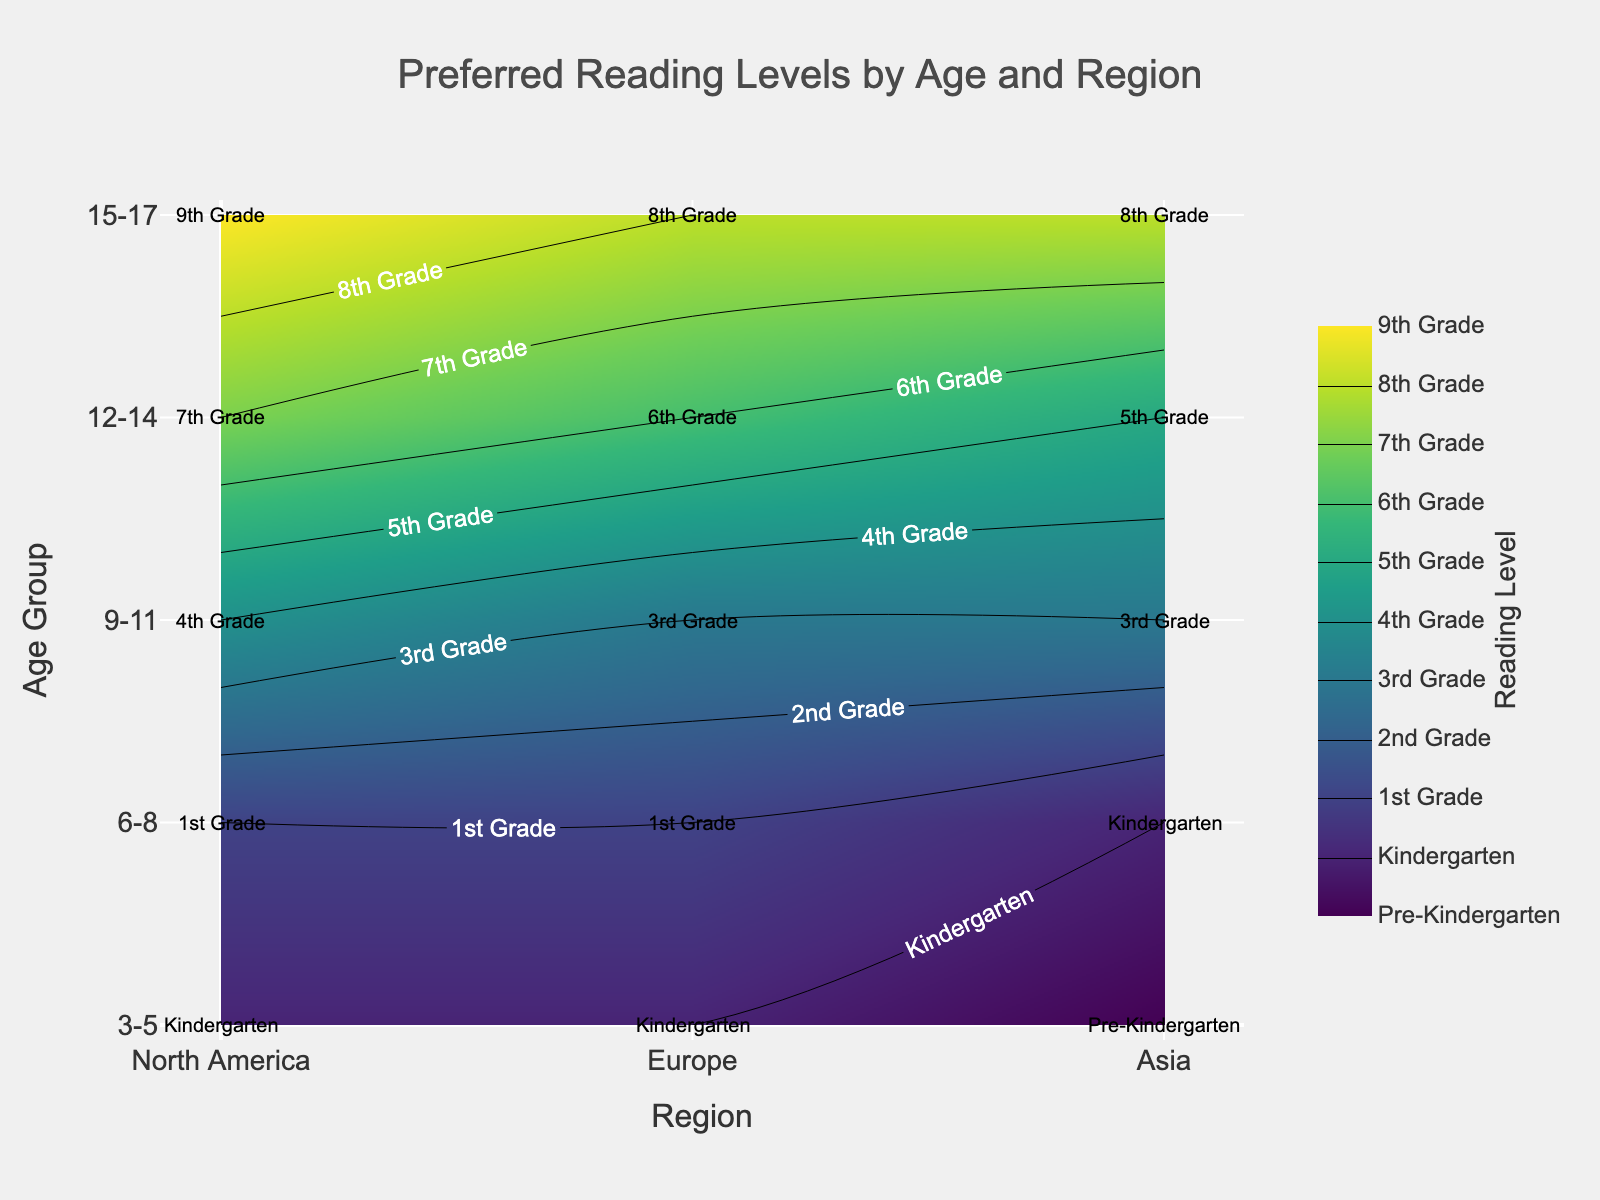What is the title of the figure? The title is displayed at the top of the figure.
Answer: Preferred Reading Levels by Age and Region What does the x-axis represent in this figure? The x-axis represents different regions, which are labeled using text such as North America, Europe, and Asia.
Answer: Regions Which age group prefers Pre-Kindergarten reading level in Asia? From the labels on the plot, we can see that the area corresponding to '3-5' age group and 'Asia' region is marked with 'Pre-Kindergarten'.
Answer: 3-5 What reading level is most preferred by the age group 12-14 in Europe? The plot shows that for the age group '12-14' in the 'Europe' region, the contour label indicates '6th Grade'.
Answer: 6th Grade Compare the preferred reading levels for the 9-11 age group across all regions. Which region has the highest reading level? By examining the contour labels for the 9-11 age group across all regions, we see the labels are '4th Grade' for North America, '3rd Grade' for Europe, and '3rd Grade' for Asia. North America has the highest reading level.
Answer: North America What is the difference in preferred reading levels between the age groups 9-11 and 15-17 in North America? For North America, the plot shows '4th Grade' for the 9-11 age group and '9th Grade' for the 15-17 age group. The difference between these reading levels is 5 grades.
Answer: 5 grades Which reading level is most frequently preferred by children aged 6-8 across all regions? For the age group '6-8', the contour labels indicate '1st Grade' for North America and Europe, and 'Kindergarten' for Asia. '1st Grade' is most frequently preferred.
Answer: 1st Grade What patterns can be observed in the preferred reading levels as age increases across all regions? The contour plot shows an upward trend in reading levels as the age increases in all regions. For example, younger age groups like 3-5 prefer lower levels like 'Kindergarten', while older age groups like 15-17 prefer higher levels like '8th Grade' and '9th Grade'.
Answer: Increasing reading levels with age How do the reading levels for children aged 3-5 differ across North America, Europe, and Asia? For the age group 3-5, the plot shows 'Kindergarten' for both North America and Europe, and 'Pre-Kindergarten' for Asia. Therefore, North America and Europe have the same reading level, which is higher than Asia's pre-Kindergarten level.
Answer: North America and Europe: Kindergarten, Asia: Pre-Kindergarten 